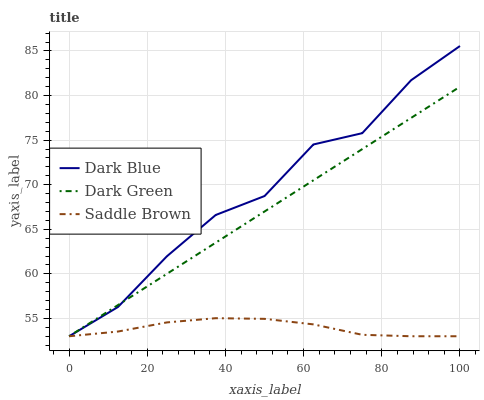Does Saddle Brown have the minimum area under the curve?
Answer yes or no. Yes. Does Dark Blue have the maximum area under the curve?
Answer yes or no. Yes. Does Dark Green have the minimum area under the curve?
Answer yes or no. No. Does Dark Green have the maximum area under the curve?
Answer yes or no. No. Is Dark Green the smoothest?
Answer yes or no. Yes. Is Dark Blue the roughest?
Answer yes or no. Yes. Is Saddle Brown the smoothest?
Answer yes or no. No. Is Saddle Brown the roughest?
Answer yes or no. No. Does Dark Blue have the lowest value?
Answer yes or no. Yes. Does Dark Blue have the highest value?
Answer yes or no. Yes. Does Dark Green have the highest value?
Answer yes or no. No. Does Dark Blue intersect Dark Green?
Answer yes or no. Yes. Is Dark Blue less than Dark Green?
Answer yes or no. No. Is Dark Blue greater than Dark Green?
Answer yes or no. No. 